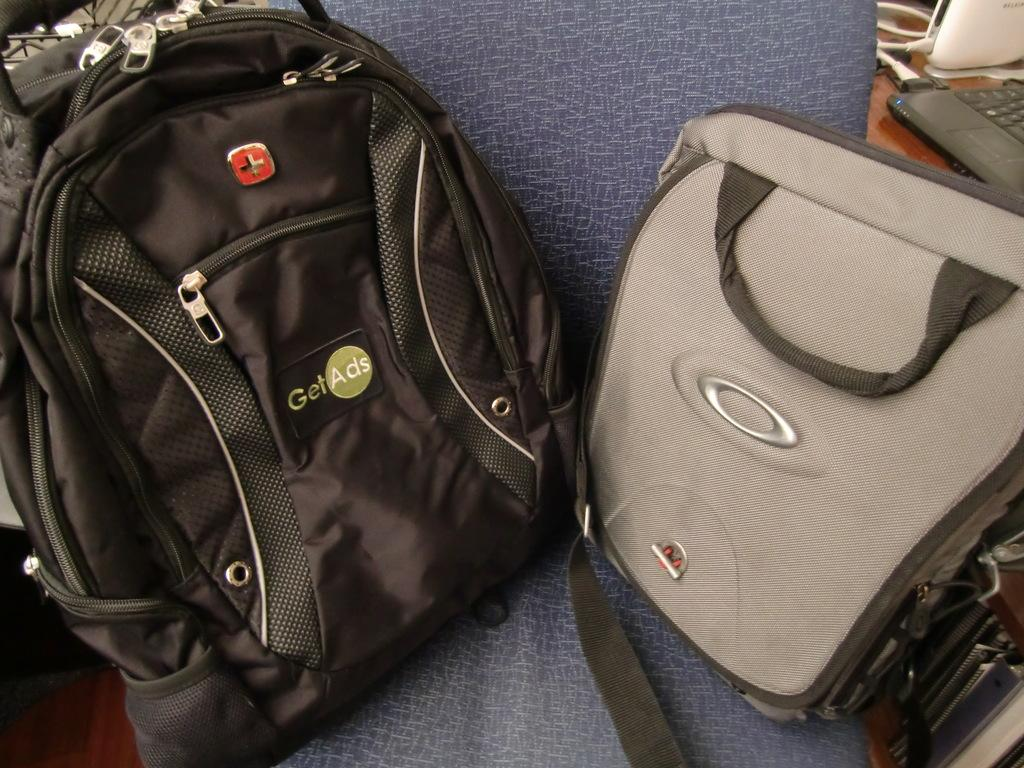How many bags are visible in the image? There are two bags in the image. Where are the bags located? The bags are on a chair. What type of friction can be observed between the bags and the chair in the image? There is no information about friction between the bags and the chair in the image. Are there any gloves visible in the image? There is no mention of gloves in the image. 